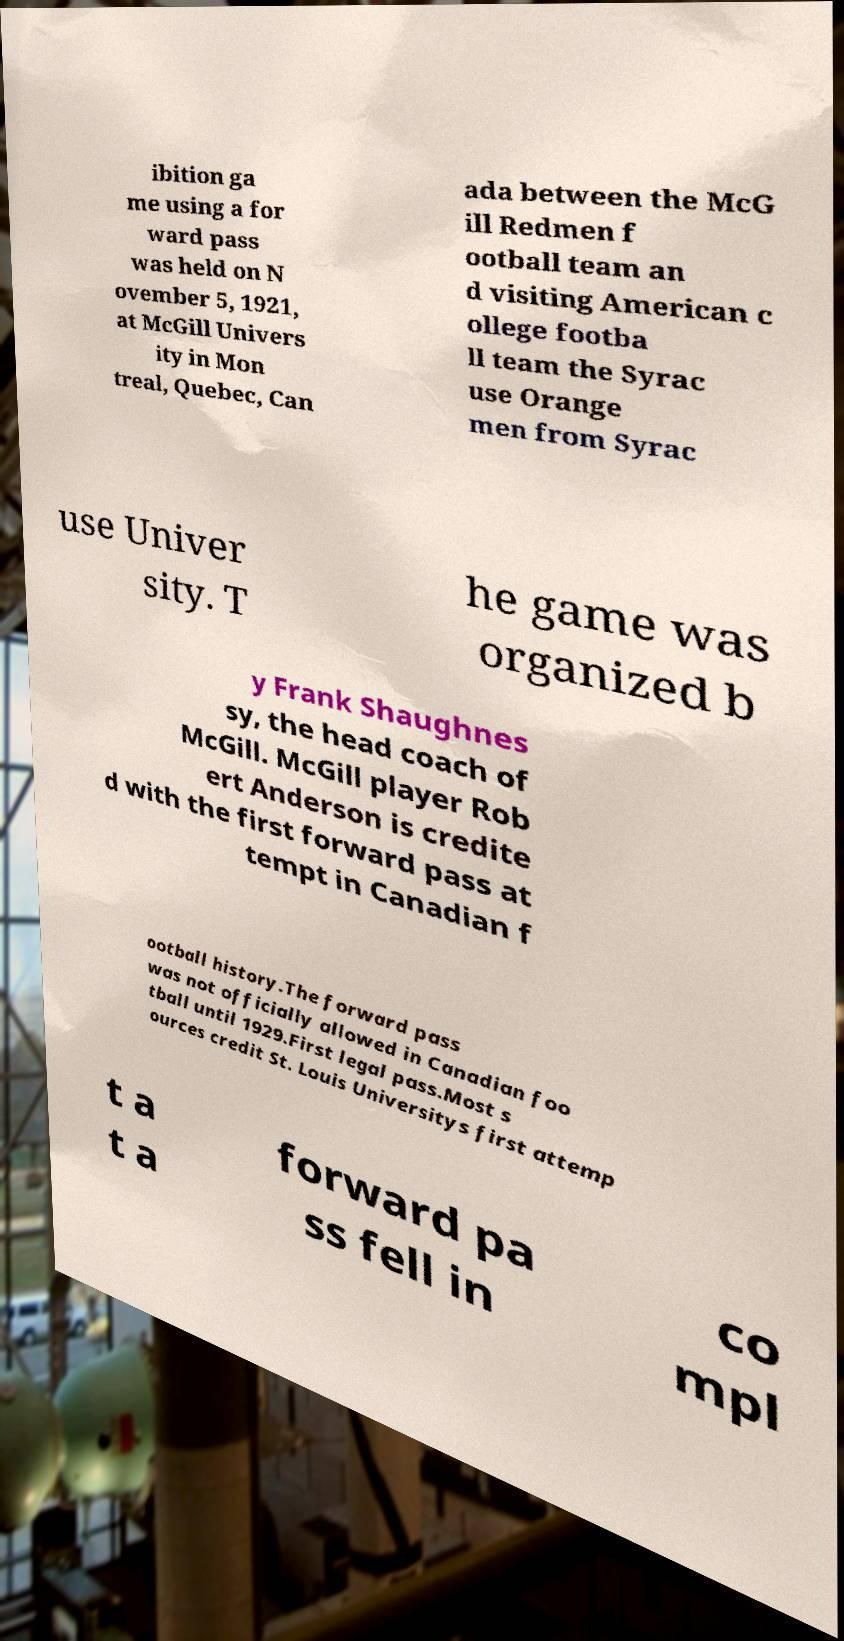For documentation purposes, I need the text within this image transcribed. Could you provide that? ibition ga me using a for ward pass was held on N ovember 5, 1921, at McGill Univers ity in Mon treal, Quebec, Can ada between the McG ill Redmen f ootball team an d visiting American c ollege footba ll team the Syrac use Orange men from Syrac use Univer sity. T he game was organized b y Frank Shaughnes sy, the head coach of McGill. McGill player Rob ert Anderson is credite d with the first forward pass at tempt in Canadian f ootball history.The forward pass was not officially allowed in Canadian foo tball until 1929.First legal pass.Most s ources credit St. Louis Universitys first attemp t a t a forward pa ss fell in co mpl 